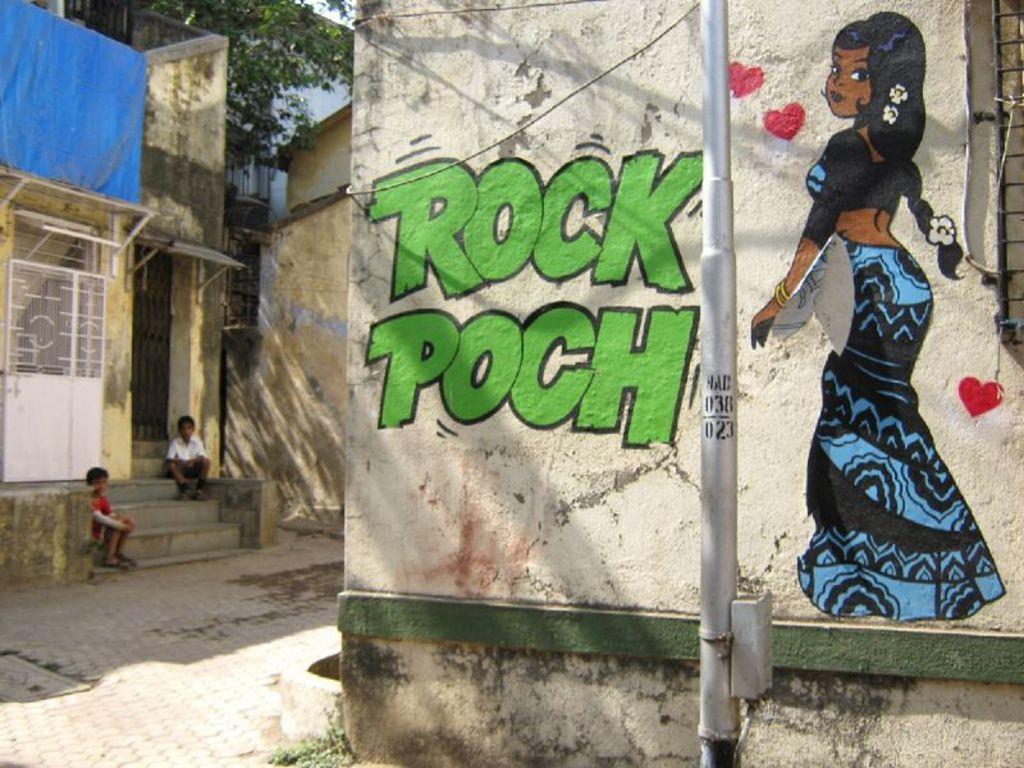Can you describe this image briefly? In this picture I can see a painting on the wall, two kids are sitting on the staircase on the left side. In the middle there are houses, at the top there is a tree. 